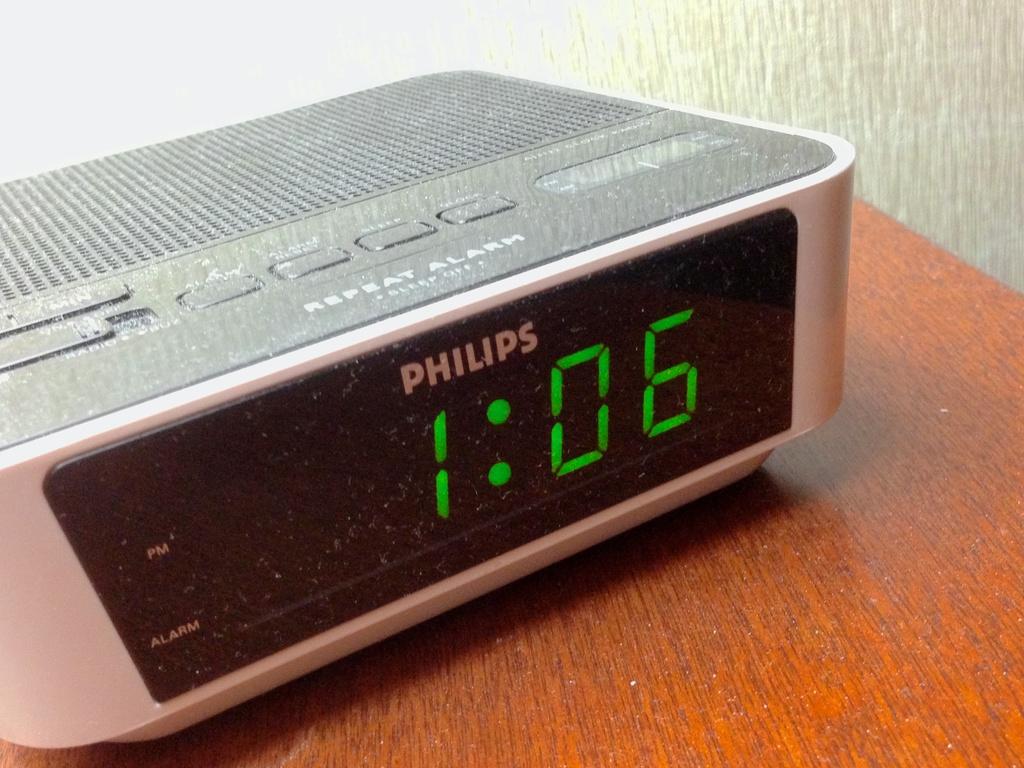What´s the brand of the alarm clock?
Provide a short and direct response. Philips. 